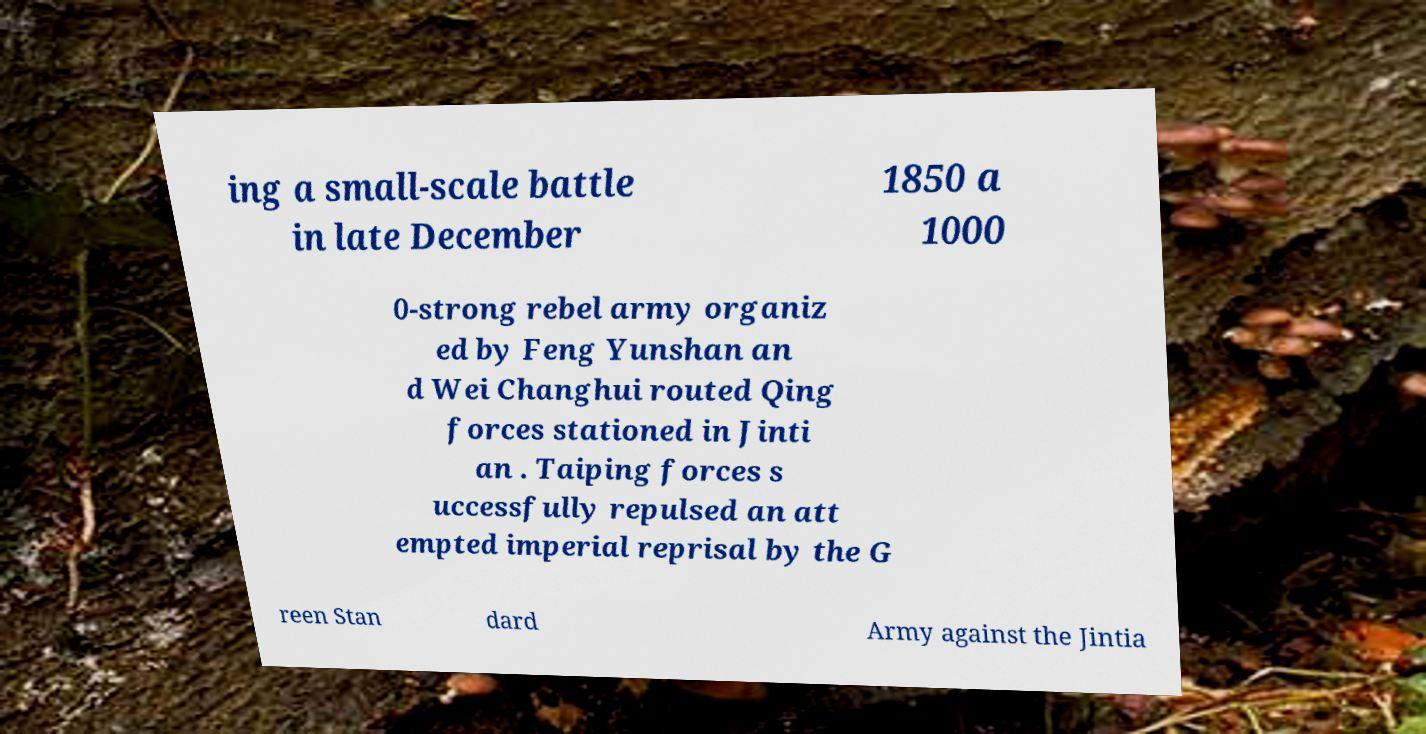Please identify and transcribe the text found in this image. ing a small-scale battle in late December 1850 a 1000 0-strong rebel army organiz ed by Feng Yunshan an d Wei Changhui routed Qing forces stationed in Jinti an . Taiping forces s uccessfully repulsed an att empted imperial reprisal by the G reen Stan dard Army against the Jintia 